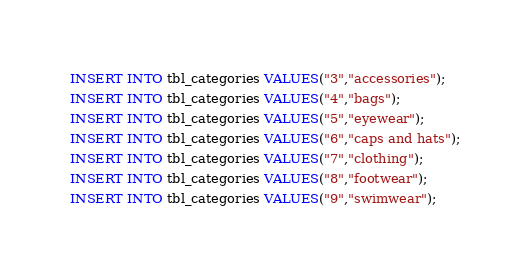Convert code to text. <code><loc_0><loc_0><loc_500><loc_500><_SQL_>


INSERT INTO tbl_categories VALUES("3","accessories");
INSERT INTO tbl_categories VALUES("4","bags");
INSERT INTO tbl_categories VALUES("5","eyewear");
INSERT INTO tbl_categories VALUES("6","caps and hats");
INSERT INTO tbl_categories VALUES("7","clothing");
INSERT INTO tbl_categories VALUES("8","footwear");
INSERT INTO tbl_categories VALUES("9","swimwear");


</code> 